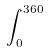Convert formula to latex. <formula><loc_0><loc_0><loc_500><loc_500>\int _ { 0 } ^ { 3 6 0 }</formula> 